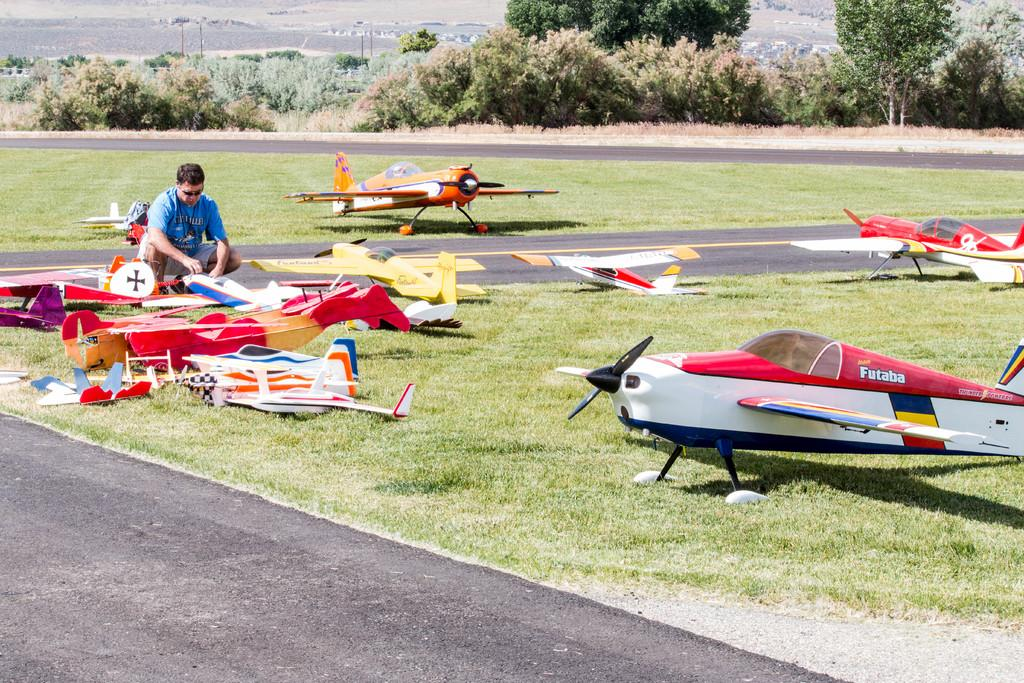What can be seen on the grass in the image? There are planes on the grass in the image. Who is present in the image? There is a man in the image. What type of infrastructure can be seen in the image? There are roads visible in the image. What is visible in the background of the image? There are trees and other objects visible in the background of the image. What type of room is visible in the image? There is no room visible in the image; it features planes on the grass, a man, roads, trees, and other objects in the background. How much was the payment for the son's education in the image? There is no information about payment or education in the image; it focuses on planes, a man, roads, trees, and other objects in the background. 